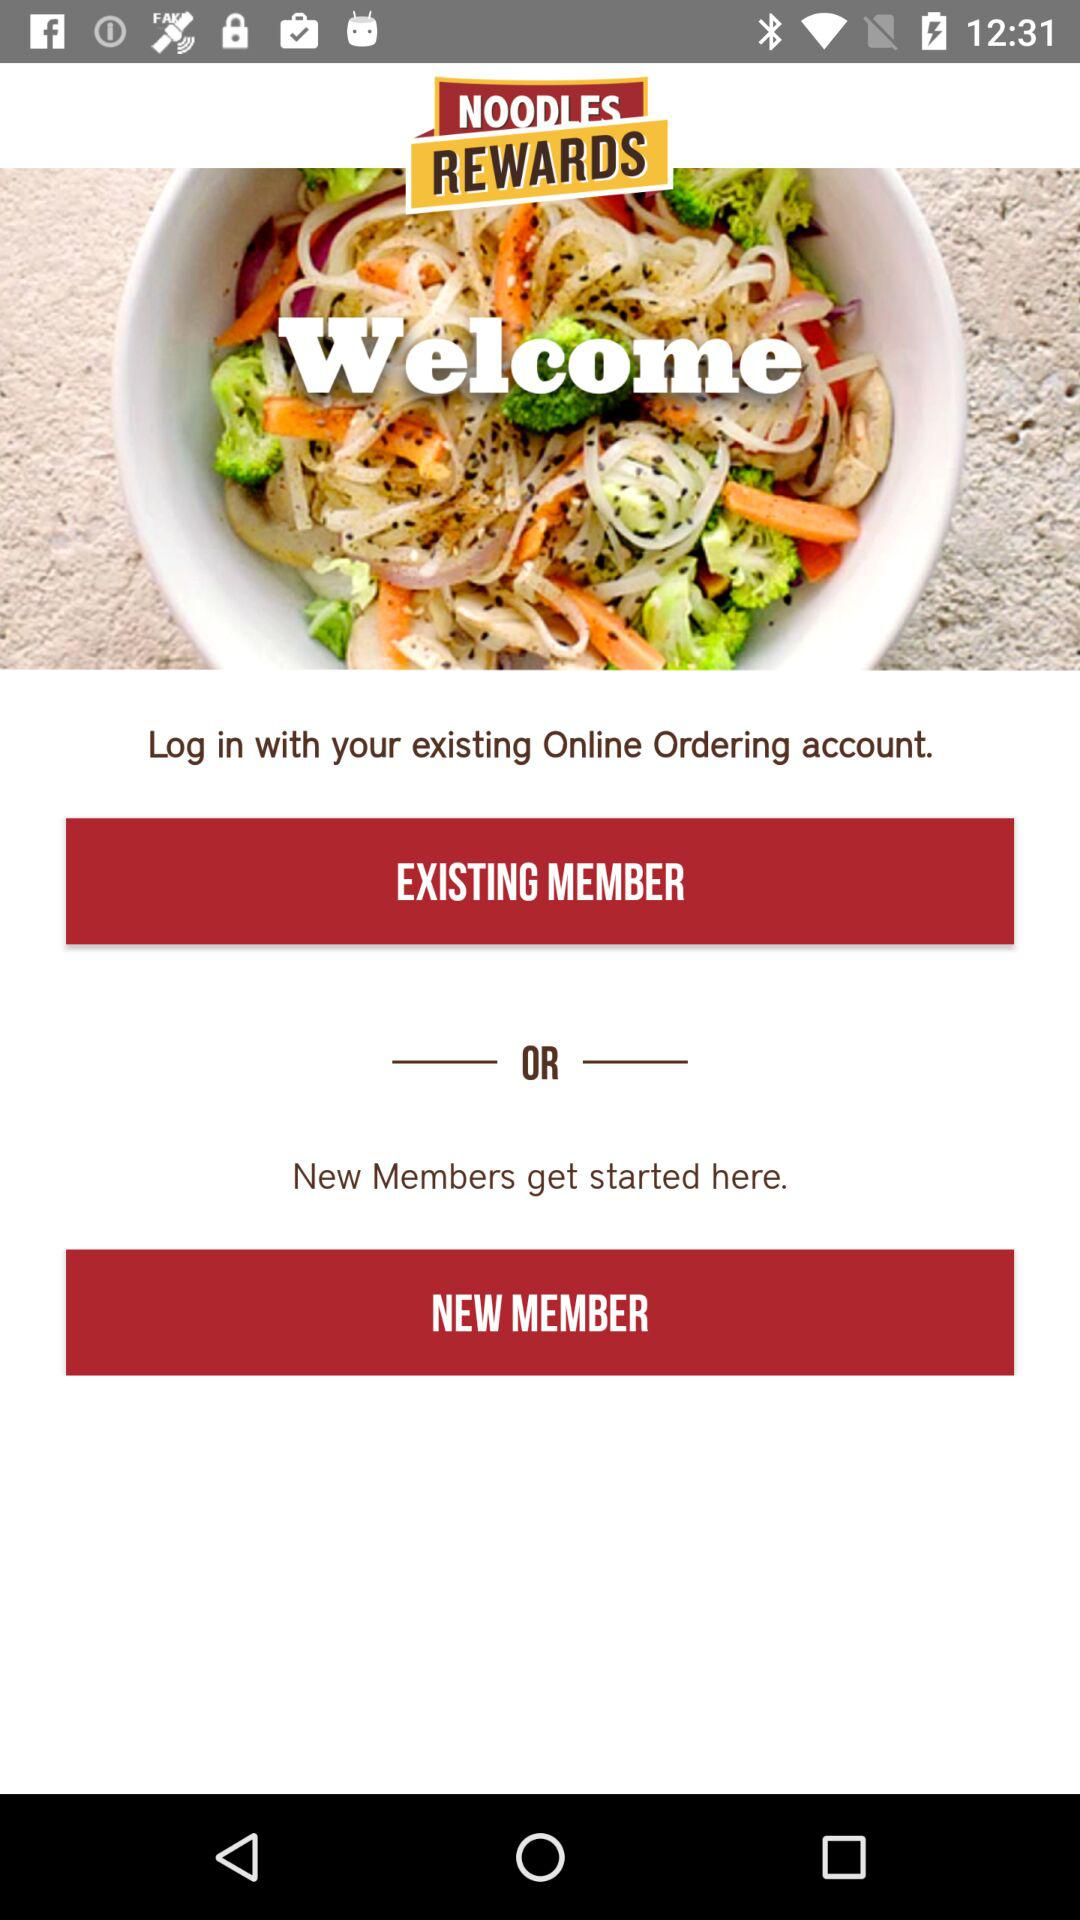What are the options to log in? The options to log in are "EXISTING MEMBER" and "NEW MEMBER". 